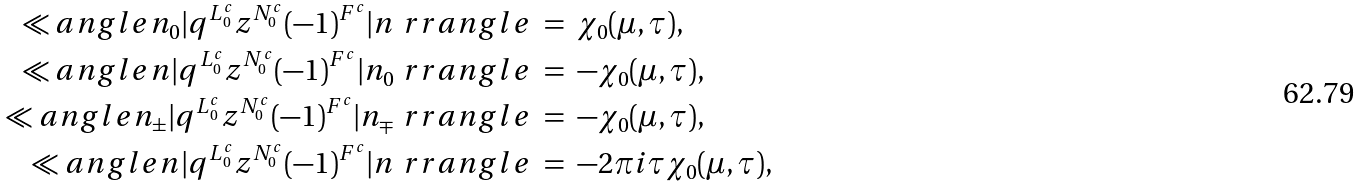Convert formula to latex. <formula><loc_0><loc_0><loc_500><loc_500>\ll a n g l e n _ { 0 } | q ^ { L ^ { c } _ { 0 } } z ^ { N ^ { c } _ { 0 } } ( - 1 ) ^ { F ^ { c } } | n \ r r a n g l e \ & = \ \chi _ { 0 } ( \mu , \tau ) , \\ \ll a n g l e n | q ^ { L ^ { c } _ { 0 } } z ^ { N ^ { c } _ { 0 } } ( - 1 ) ^ { F ^ { c } } | n _ { 0 } \ r r a n g l e \ & = \ - \chi _ { 0 } ( \mu , \tau ) , \\ \ll a n g l e n _ { \pm } | q ^ { L ^ { c } _ { 0 } } z ^ { N ^ { c } _ { 0 } } ( - 1 ) ^ { F ^ { c } } | n _ { \mp } \ r r a n g l e \ & = \ - \chi _ { 0 } ( \mu , \tau ) , \\ \ll a n g l e n | q ^ { L ^ { c } _ { 0 } } z ^ { N ^ { c } _ { 0 } } ( - 1 ) ^ { F ^ { c } } | n \ r r a n g l e \ & = \ - 2 \pi i \tau \chi _ { 0 } ( \mu , \tau ) , \\</formula> 